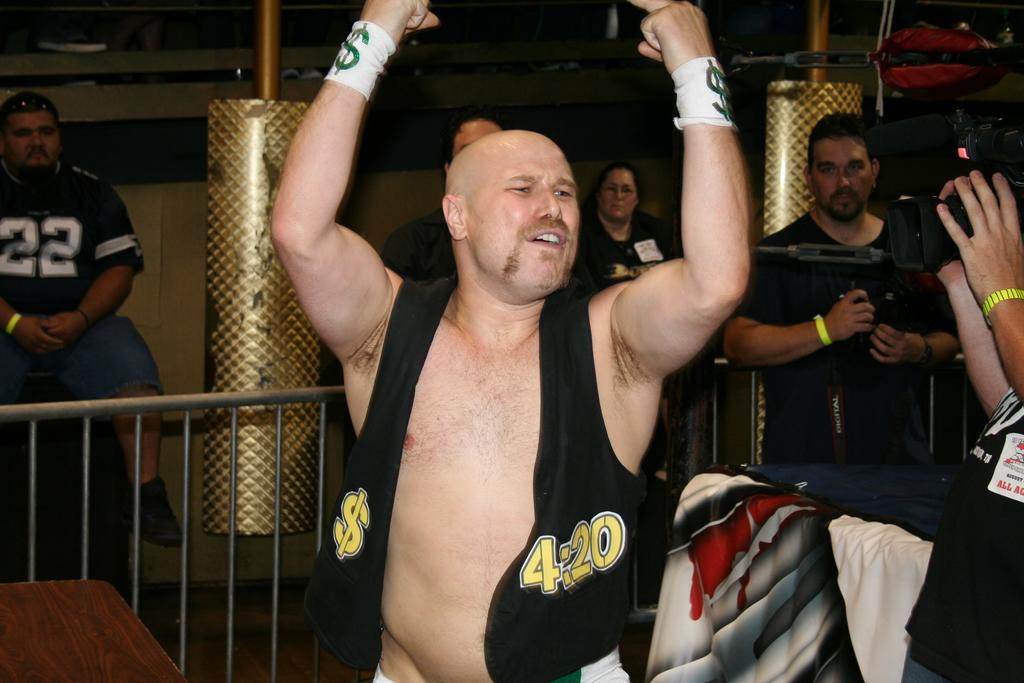<image>
Present a compact description of the photo's key features. A man with a $ symbol and  4:20 written on his vest raises his hands in the air 